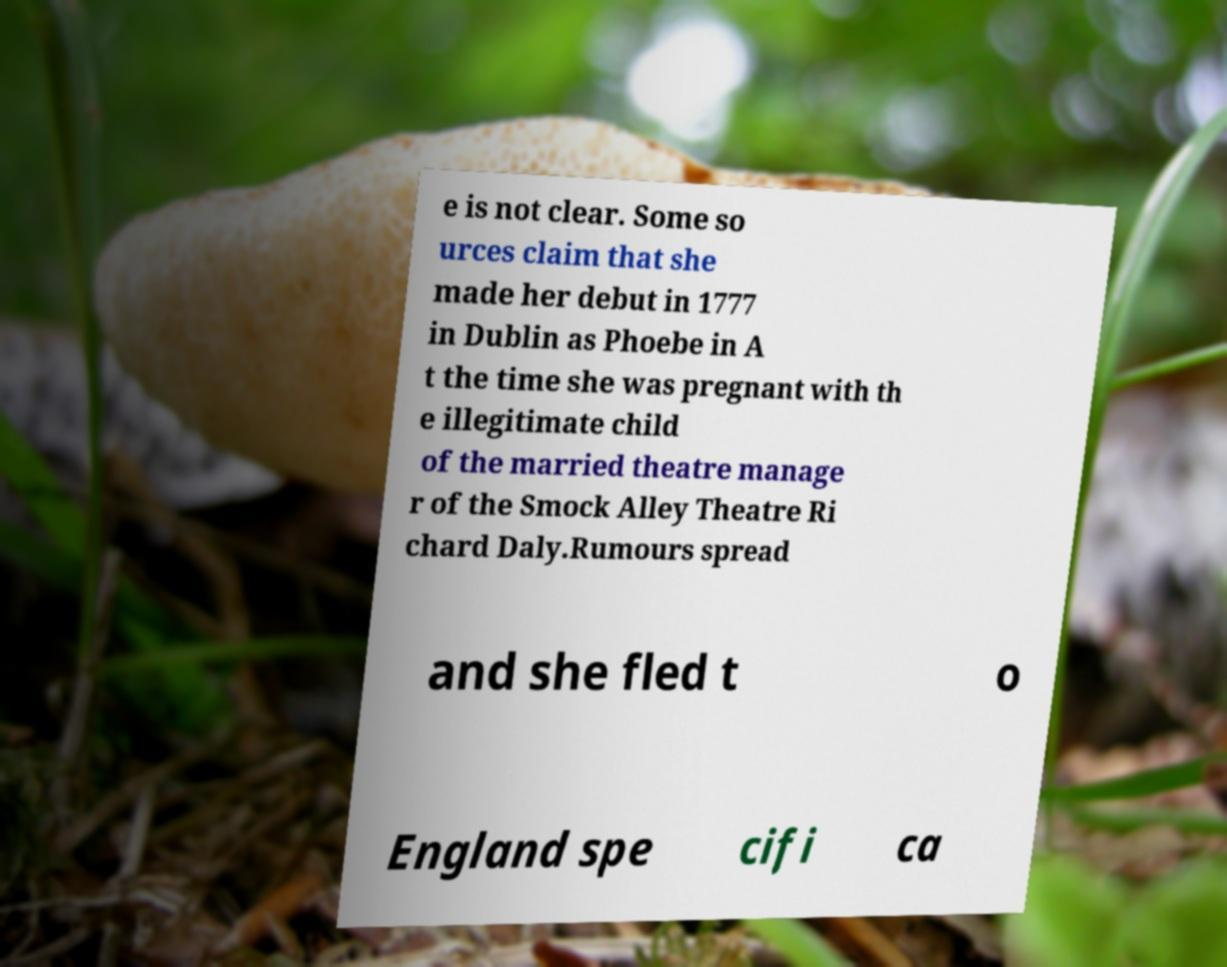What messages or text are displayed in this image? I need them in a readable, typed format. e is not clear. Some so urces claim that she made her debut in 1777 in Dublin as Phoebe in A t the time she was pregnant with th e illegitimate child of the married theatre manage r of the Smock Alley Theatre Ri chard Daly.Rumours spread and she fled t o England spe cifi ca 